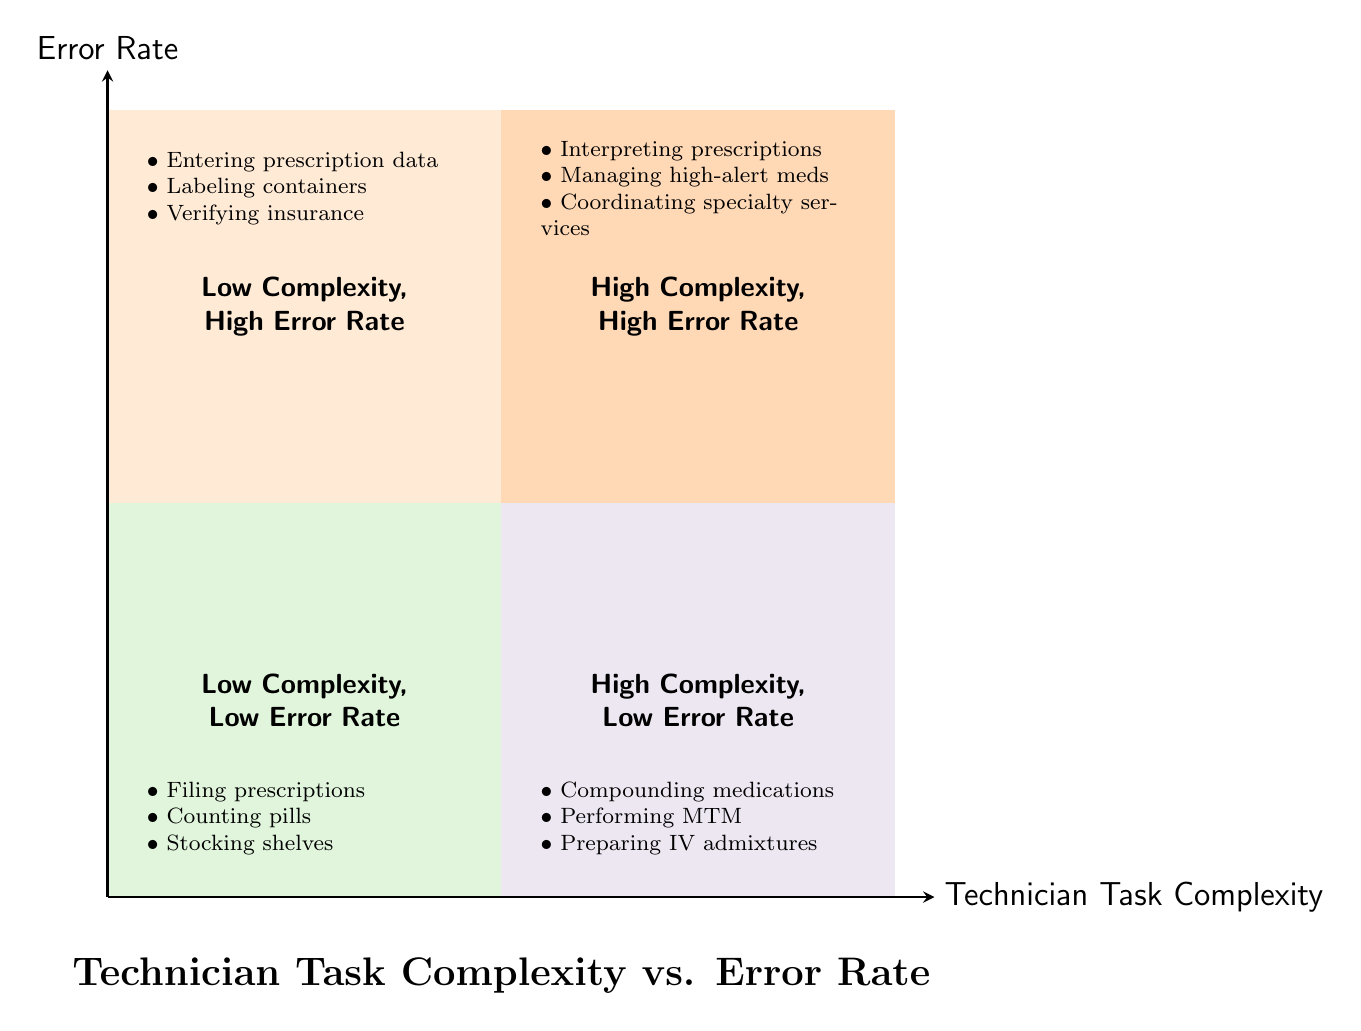What tasks are located in the Low Complexity, Low Error Rate quadrant? The Low Complexity, Low Error Rate quadrant includes tasks that are simple and performed accurately. By reviewing the indicated quadrant in the diagram, we find the specific tasks: filing prescriptions alphabetically, counting pills for a prescription, and stocking shelves with common drugs.
Answer: Filing prescriptions alphabetically, counting pills for a prescription, stocking shelves with common drugs How many quadrants are in the diagram? The diagram displays a total of four quadrants. This can be confirmed by counting each of the colored areas that define different task complexity and error rates, showing the various combinations.
Answer: Four Which quadrant contains preparing intravenous admixtures? To determine the correct quadrant, we check the task "preparing intravenous admixtures." As per the diagram, this task falls under the High Complexity, Low Error Rate quadrant. This is indicated by the description and examples provided in that specific section.
Answer: High Complexity, Low Error Rate What is the relationship between task complexity and error rate in the Low Complexity, High Error Rate quadrant? In the Low Complexity, High Error Rate quadrant, the tasks are characterized by being simple yet prone to mistakes. This indicates that the tasks require basic skills but are still performed inaccurately due to oversight or human error. Thus, the complexity is low while the error rate is high.
Answer: Simple but prone to mistakes Which quadrant is most likely to require additional supervision? Referring to the description of each quadrant, the High Complexity, High Error Rate quadrant is specifically noted for requiring more supervision and double-checks. The tasks listed in this quadrant involve complex processes and a higher risk of errors, making supervision essential.
Answer: High Complexity, High Error Rate 